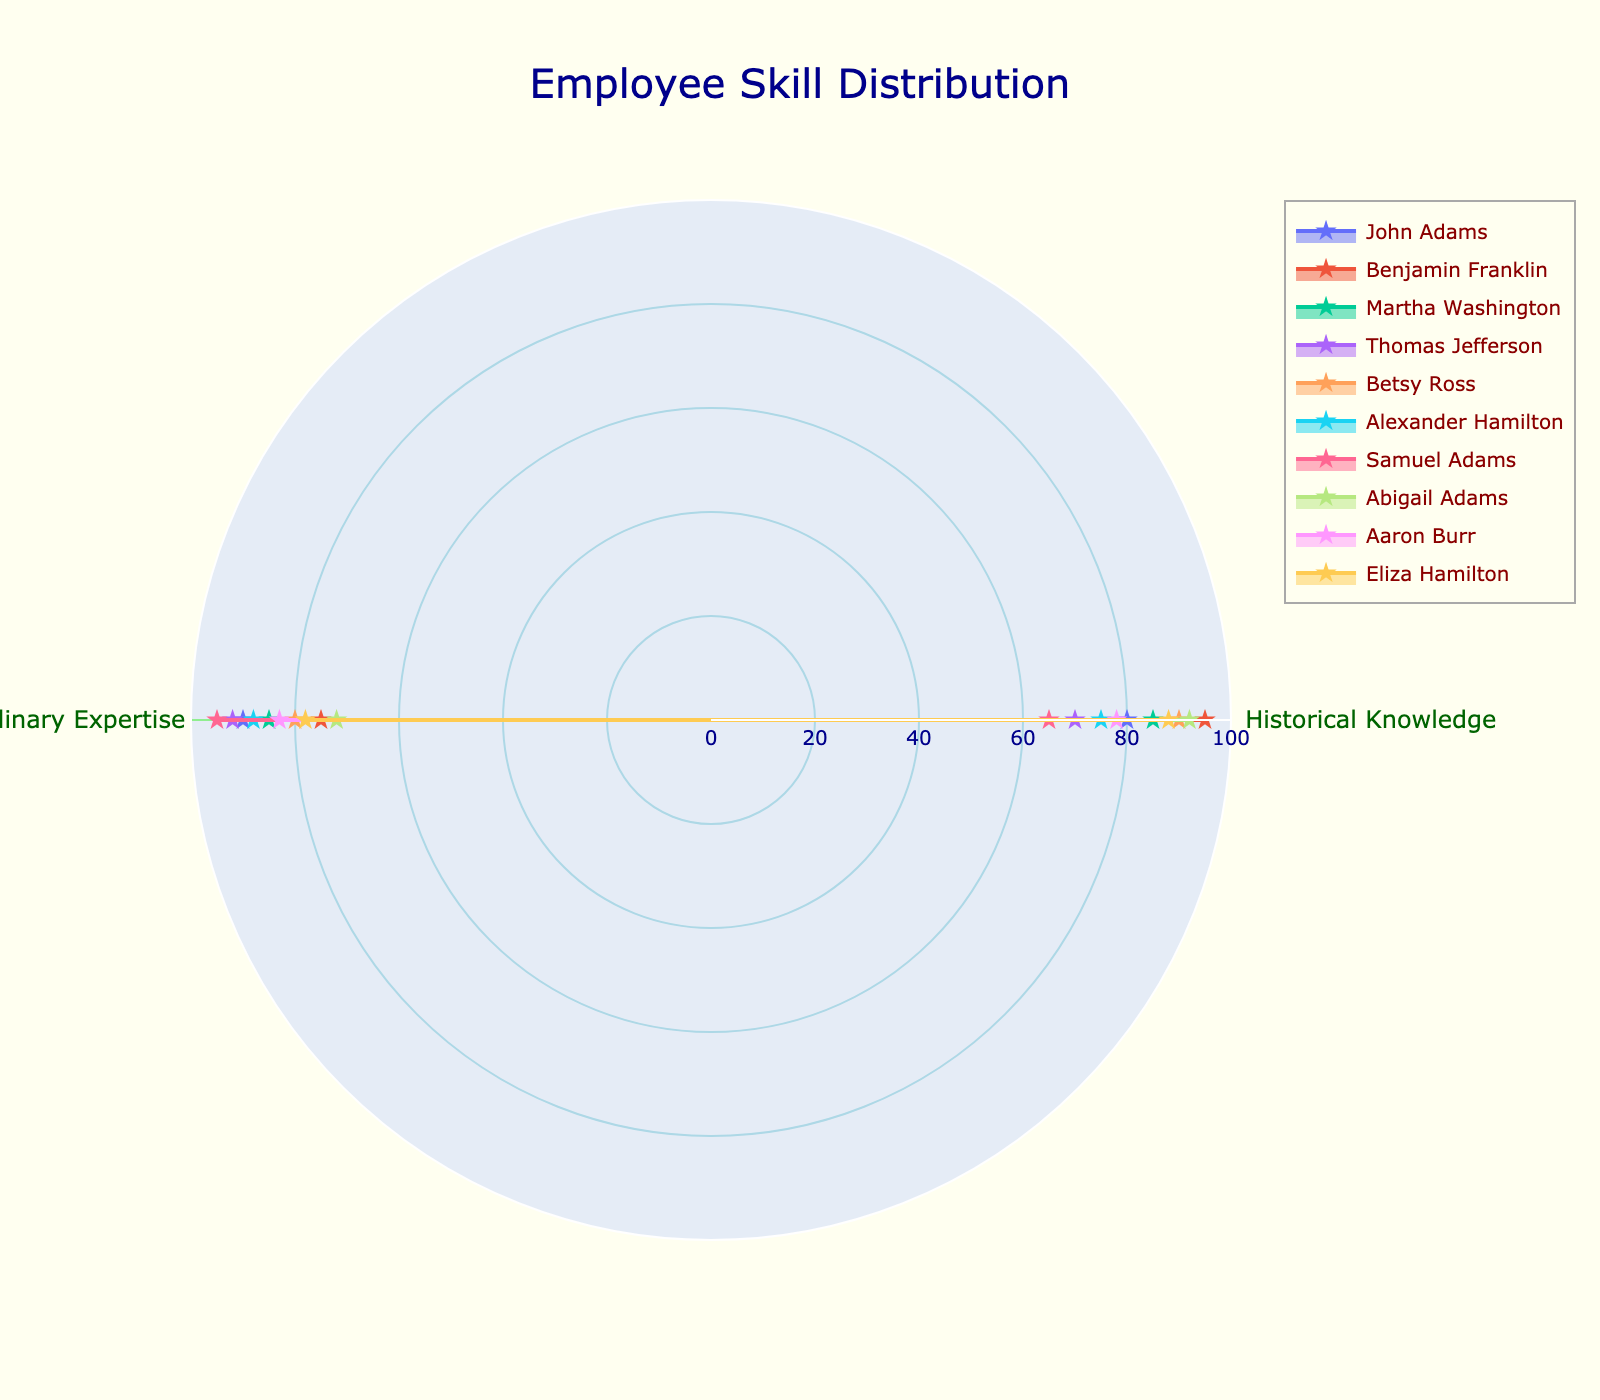what is the title of the figure? The title of the figure is usually located at the top center. In this case, the title is clearly described in the layout updates.
Answer: Employee Skill Distribution when looking at the historical knowledge axis, which employee appears to have the highest value? To find the highest value on the historical knowledge axis, look at the radar chart and identify the employee whose data point is at the maximum level on that axis. According to the dataset, Benjamin Franklin has the highest Historical Knowledge value of 95.
Answer: Benjamin Franklin which employee has the lowest value in culinary expertise? By inspecting the radar chart for the lowest value on the culinary expertise axis, we see that Abigail Adams has the lowest score in this category with a score of 72.
Answer: Abigail Adams compare john adams and thomas jefferson, who is more skilled in culinary expertise? Compare the data points of John Adams and Thomas Jefferson on the culinary expertise axis. John Adams has a score of 90, while Thomas Jefferson has a slightly higher score of 92.
Answer: Thomas Jefferson which employee has the most balanced skills in both historical knowledge and culinary expertise? Balanced skills mean the scores in both categories are close to each other. Martha Washington with scores of 85 in both historical knowledge and culinary expertise, seems the most balanced.
Answer: Martha Washington find the difference in culinary expertise between the employee with the highest and the lowest value Samuel Adams has the highest culinary expertise score of 95, and Abigail Adams has the lowest score of 72. The difference is 95 - 72 = 23.
Answer: 23 what is the average culinary expertise score of all employees? To find the average, sum up all culinary expertise scores and divide by the number of employees. (90 + 75 + 85 + 92 + 80 + 88 + 95 + 72 + 83 + 78) ÷ 10 = 83.8.
Answer: 83.8 which employee has the higher historical knowledge score between alexander hamilton and eliza hamilton? Compare the historical knowledge scores for both employees. Alexander Hamilton has a score of 75, while Eliza Hamilton has a score of 88.
Answer: Eliza Hamilton do any two employees have equal values for culinary expertise? By reviewing the radar chart or dataset, we see that none of the employees have exactly the same culinary expertise scores.
Answer: no 